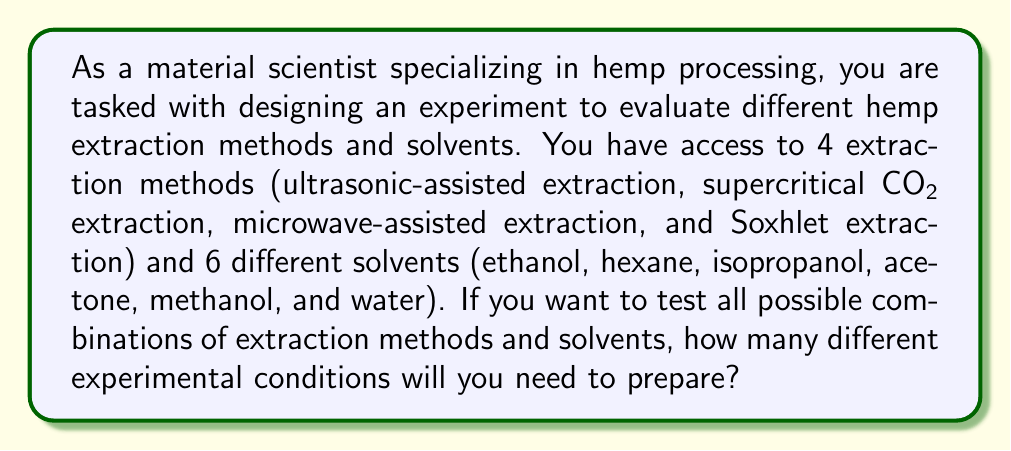Help me with this question. To solve this problem, we need to apply the multiplication principle of counting. This principle states that if we have two independent events, where one event can occur in $m$ ways and the other in $n$ ways, then the two events can occur together in $m \times n$ ways.

In this case, we have:
1. Extraction methods: 4 options
2. Solvents: 6 options

Each extraction method can be paired with each solvent, and these choices are independent of each other. Therefore, we can apply the multiplication principle:

$$ \text{Total combinations} = \text{Number of extraction methods} \times \text{Number of solvents} $$

$$ \text{Total combinations} = 4 \times 6 $$

$$ \text{Total combinations} = 24 $$

This means that there are 24 unique combinations of extraction methods and solvents that need to be tested to cover all possible experimental conditions.
Answer: 24 experimental conditions 